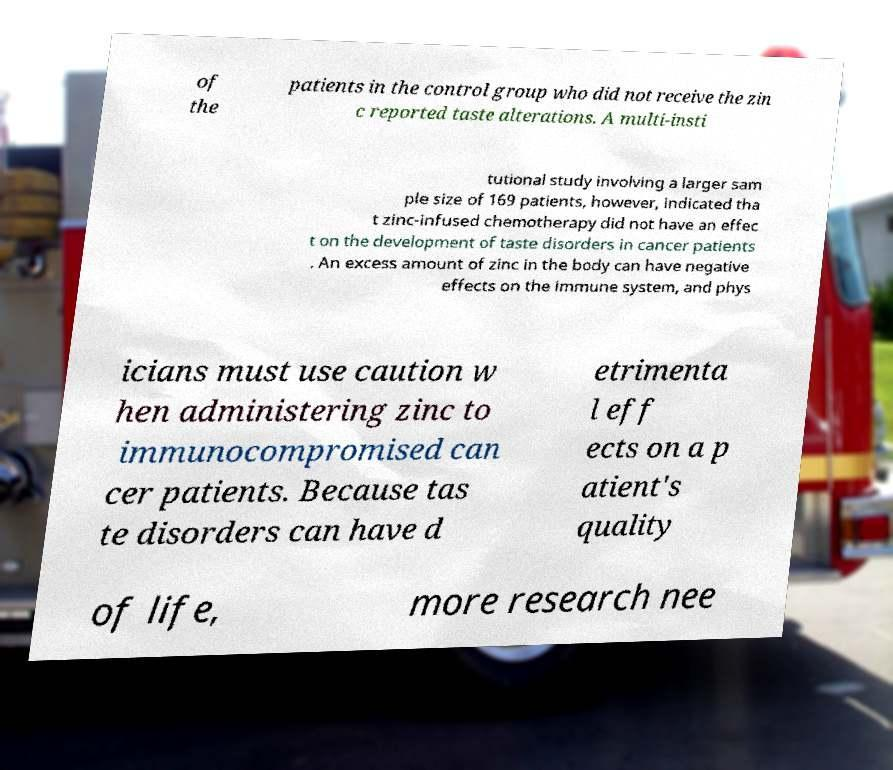Can you read and provide the text displayed in the image?This photo seems to have some interesting text. Can you extract and type it out for me? of the patients in the control group who did not receive the zin c reported taste alterations. A multi-insti tutional study involving a larger sam ple size of 169 patients, however, indicated tha t zinc-infused chemotherapy did not have an effec t on the development of taste disorders in cancer patients . An excess amount of zinc in the body can have negative effects on the immune system, and phys icians must use caution w hen administering zinc to immunocompromised can cer patients. Because tas te disorders can have d etrimenta l eff ects on a p atient's quality of life, more research nee 